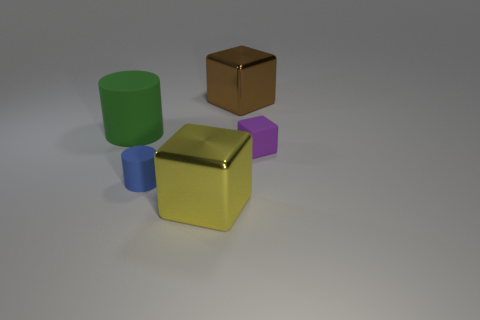Is the yellow cube made of the same material as the cylinder behind the blue thing?
Your response must be concise. No. Is the number of brown cylinders greater than the number of blue objects?
Give a very brief answer. No. How many cubes are either blue metallic objects or purple things?
Your response must be concise. 1. The large rubber cylinder has what color?
Keep it short and to the point. Green. There is a shiny block in front of the big brown metal thing; does it have the same size as the thing that is behind the large cylinder?
Your answer should be very brief. Yes. Is the number of large blue things less than the number of small purple rubber cubes?
Provide a short and direct response. Yes. What number of blue matte cylinders are to the left of the green rubber object?
Offer a terse response. 0. What is the material of the small cylinder?
Ensure brevity in your answer.  Rubber. Are there fewer tiny purple matte blocks that are behind the yellow metal block than matte things?
Your response must be concise. Yes. There is a matte object behind the purple cube; what color is it?
Your answer should be compact. Green. 